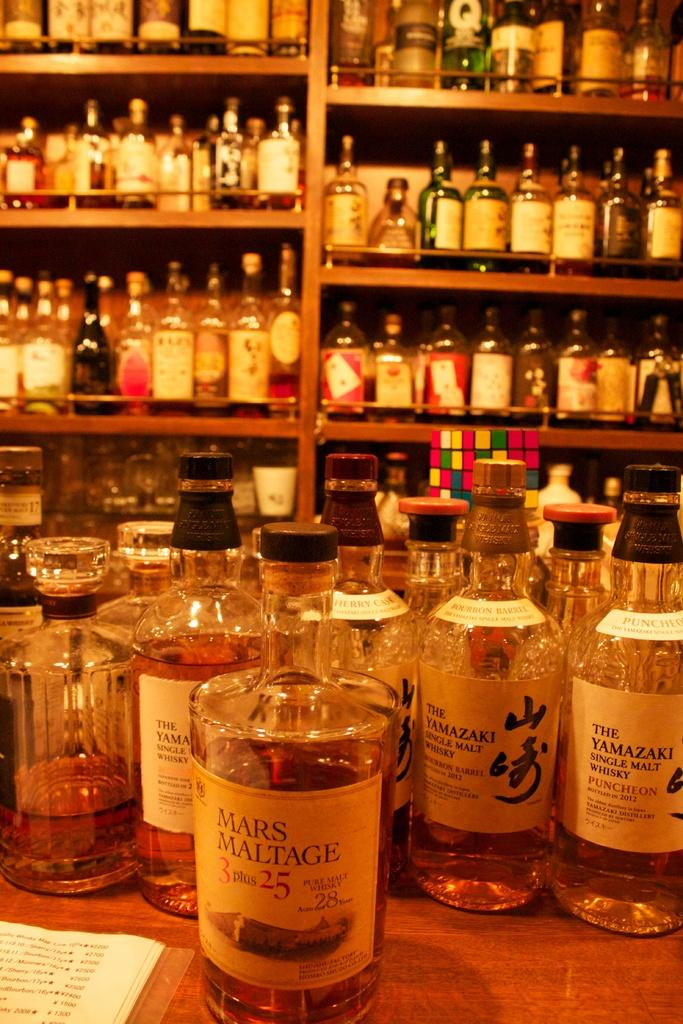Provide a one-sentence caption for the provided image. Several bottles of whiskey, one with "Mars Maltage" on the label. 